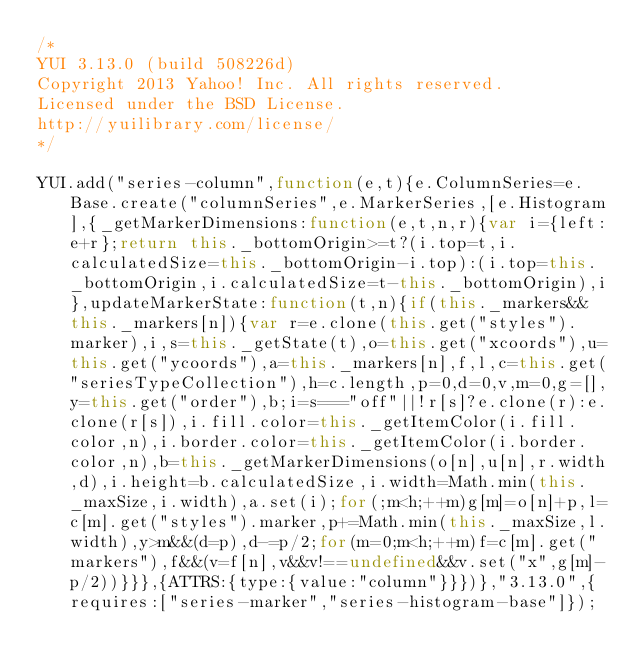<code> <loc_0><loc_0><loc_500><loc_500><_JavaScript_>/*
YUI 3.13.0 (build 508226d)
Copyright 2013 Yahoo! Inc. All rights reserved.
Licensed under the BSD License.
http://yuilibrary.com/license/
*/

YUI.add("series-column",function(e,t){e.ColumnSeries=e.Base.create("columnSeries",e.MarkerSeries,[e.Histogram],{_getMarkerDimensions:function(e,t,n,r){var i={left:e+r};return this._bottomOrigin>=t?(i.top=t,i.calculatedSize=this._bottomOrigin-i.top):(i.top=this._bottomOrigin,i.calculatedSize=t-this._bottomOrigin),i},updateMarkerState:function(t,n){if(this._markers&&this._markers[n]){var r=e.clone(this.get("styles").marker),i,s=this._getState(t),o=this.get("xcoords"),u=this.get("ycoords"),a=this._markers[n],f,l,c=this.get("seriesTypeCollection"),h=c.length,p=0,d=0,v,m=0,g=[],y=this.get("order"),b;i=s==="off"||!r[s]?e.clone(r):e.clone(r[s]),i.fill.color=this._getItemColor(i.fill.color,n),i.border.color=this._getItemColor(i.border.color,n),b=this._getMarkerDimensions(o[n],u[n],r.width,d),i.height=b.calculatedSize,i.width=Math.min(this._maxSize,i.width),a.set(i);for(;m<h;++m)g[m]=o[n]+p,l=c[m].get("styles").marker,p+=Math.min(this._maxSize,l.width),y>m&&(d=p),d-=p/2;for(m=0;m<h;++m)f=c[m].get("markers"),f&&(v=f[n],v&&v!==undefined&&v.set("x",g[m]-p/2))}}},{ATTRS:{type:{value:"column"}}})},"3.13.0",{requires:["series-marker","series-histogram-base"]});
</code> 